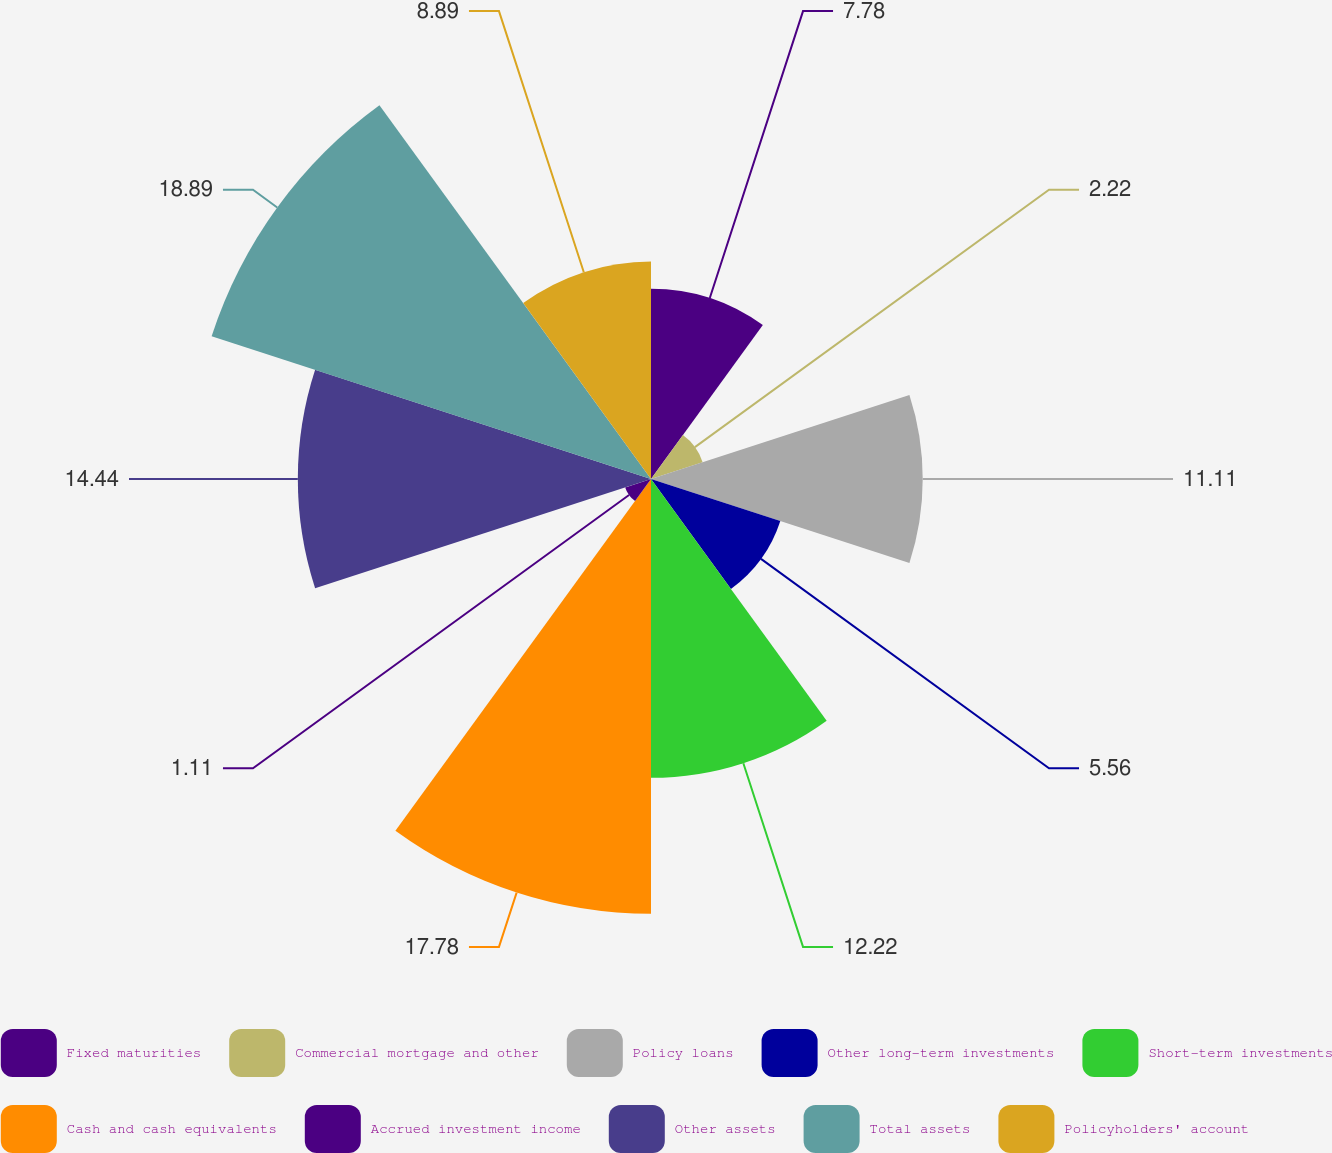Convert chart to OTSL. <chart><loc_0><loc_0><loc_500><loc_500><pie_chart><fcel>Fixed maturities<fcel>Commercial mortgage and other<fcel>Policy loans<fcel>Other long-term investments<fcel>Short-term investments<fcel>Cash and cash equivalents<fcel>Accrued investment income<fcel>Other assets<fcel>Total assets<fcel>Policyholders' account<nl><fcel>7.78%<fcel>2.22%<fcel>11.11%<fcel>5.56%<fcel>12.22%<fcel>17.78%<fcel>1.11%<fcel>14.44%<fcel>18.89%<fcel>8.89%<nl></chart> 